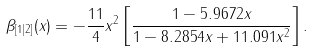<formula> <loc_0><loc_0><loc_500><loc_500>\beta _ { [ 1 | 2 ] } ( x ) = - \frac { 1 1 } { 4 } x ^ { 2 } \left [ \frac { 1 - 5 . 9 6 7 2 x } { 1 - 8 . 2 8 5 4 x + 1 1 . 0 9 1 x ^ { 2 } } \right ] .</formula> 